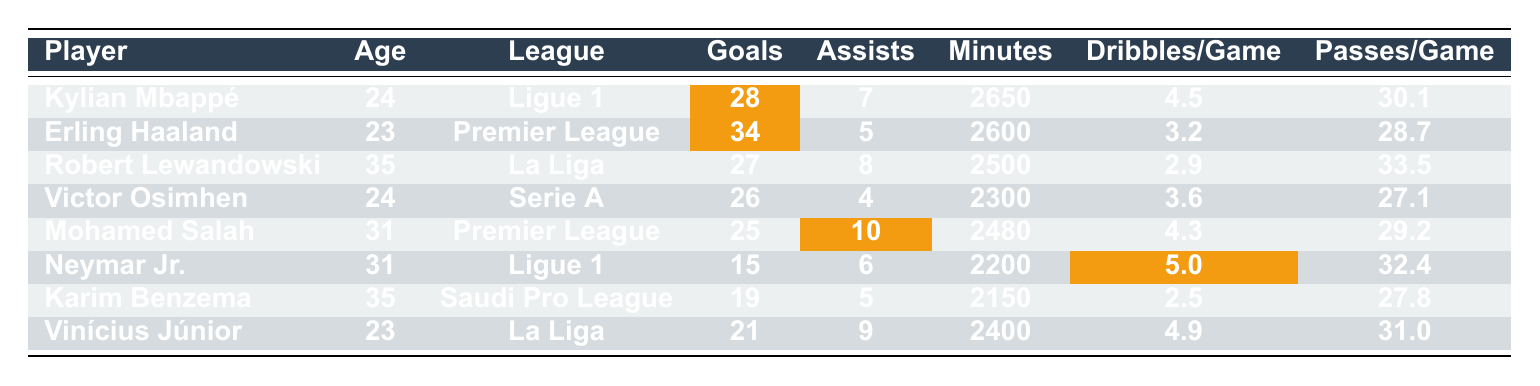What is the total number of goals scored by players in Ligue 1? Kylian Mbappé scored 28 goals and Neymar Jr. scored 15 goals. The total is 28 + 15 = 43.
Answer: 43 Who has the highest number of assists and how many did they record? Mohamed Salah has the highest number of assists with a total of 10.
Answer: 10 What is the average number of goals scored by players in the Premier League? Erling Haaland scored 34 goals and Mohamed Salah scored 25 goals. The total is 34 + 25 = 59. There are 2 players, so the average is 59 / 2 = 29.5.
Answer: 29.5 Which player has the lowest number of goals, and how many goals did they score? Neymar Jr. has the lowest number of goals with a total of 15.
Answer: 15 Is Robert Lewandowski younger than Kylian Mbappé? Robert Lewandowski is 35 years old, while Kylian Mbappé is 24 years old. Therefore, Lewandowski is not younger.
Answer: No What is the difference in the number of goals scored between the player with the most goals and the player with the least goals? Erling Haaland scored 34 goals, and Neymar Jr. scored 15 goals. The difference is 34 - 15 = 19.
Answer: 19 How many assists did players in La Liga combine for? Robert Lewandowski had 8 assists and Vinícius Júnior had 9 assists. The total is 8 + 9 = 17.
Answer: 17 Which league has the player that made the most dribbles per game, and how many did they average? Neymar Jr. in Ligue 1 has the highest average at 5.0 dribbles per game.
Answer: Ligue 1, 5.0 Who among the players listed played the fewest minutes? Karim Benzema played the fewest minutes at 2150.
Answer: 2150 If we consider only the goals, which league is the most productive based on the players listed? Ligue 1 has a total of 43 goals (28+15), Premier League has 59 goals (34+25), La Liga has 48 goals (27+21), and Serie A has 26 goals. The Premier League is the most productive with 59 goals.
Answer: Premier League 